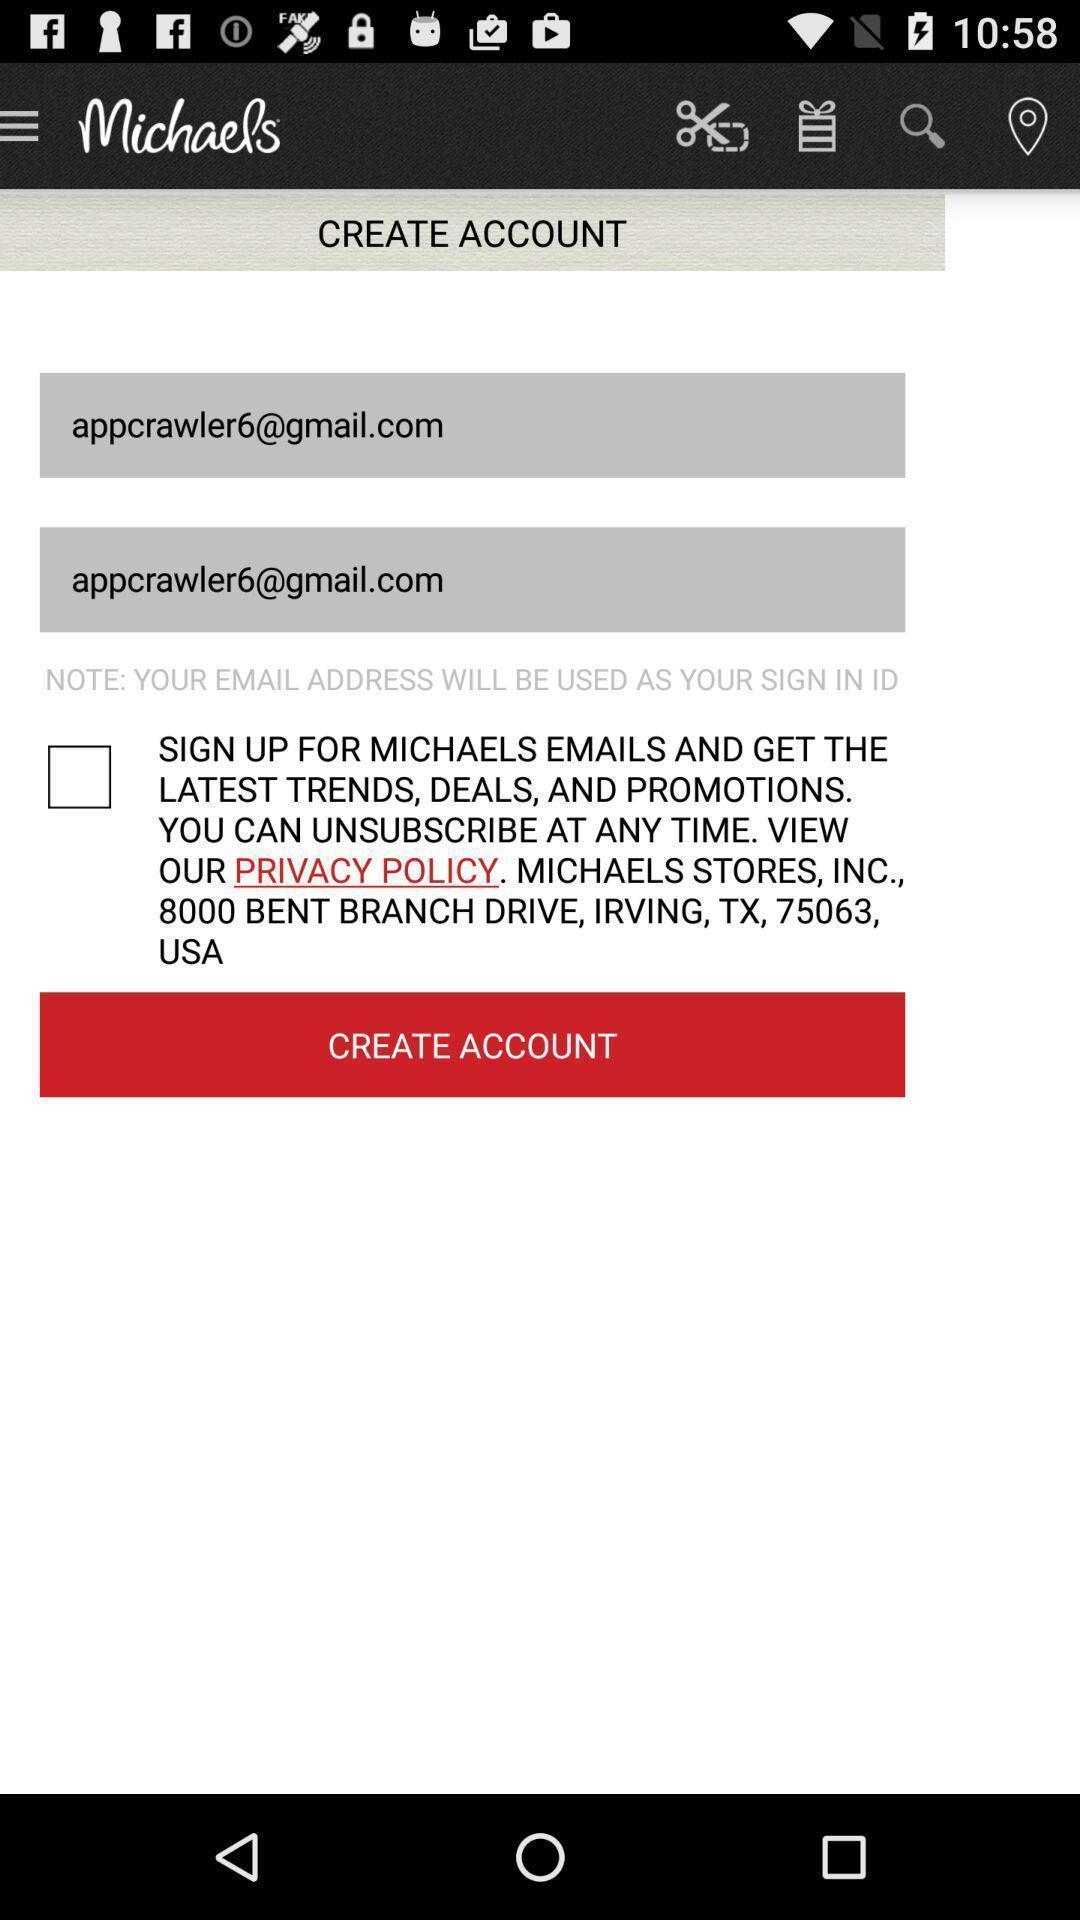Explain the elements present in this screenshot. Page displays to create an account in app. 